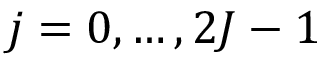Convert formula to latex. <formula><loc_0><loc_0><loc_500><loc_500>j = 0 , \dots , 2 J - 1</formula> 